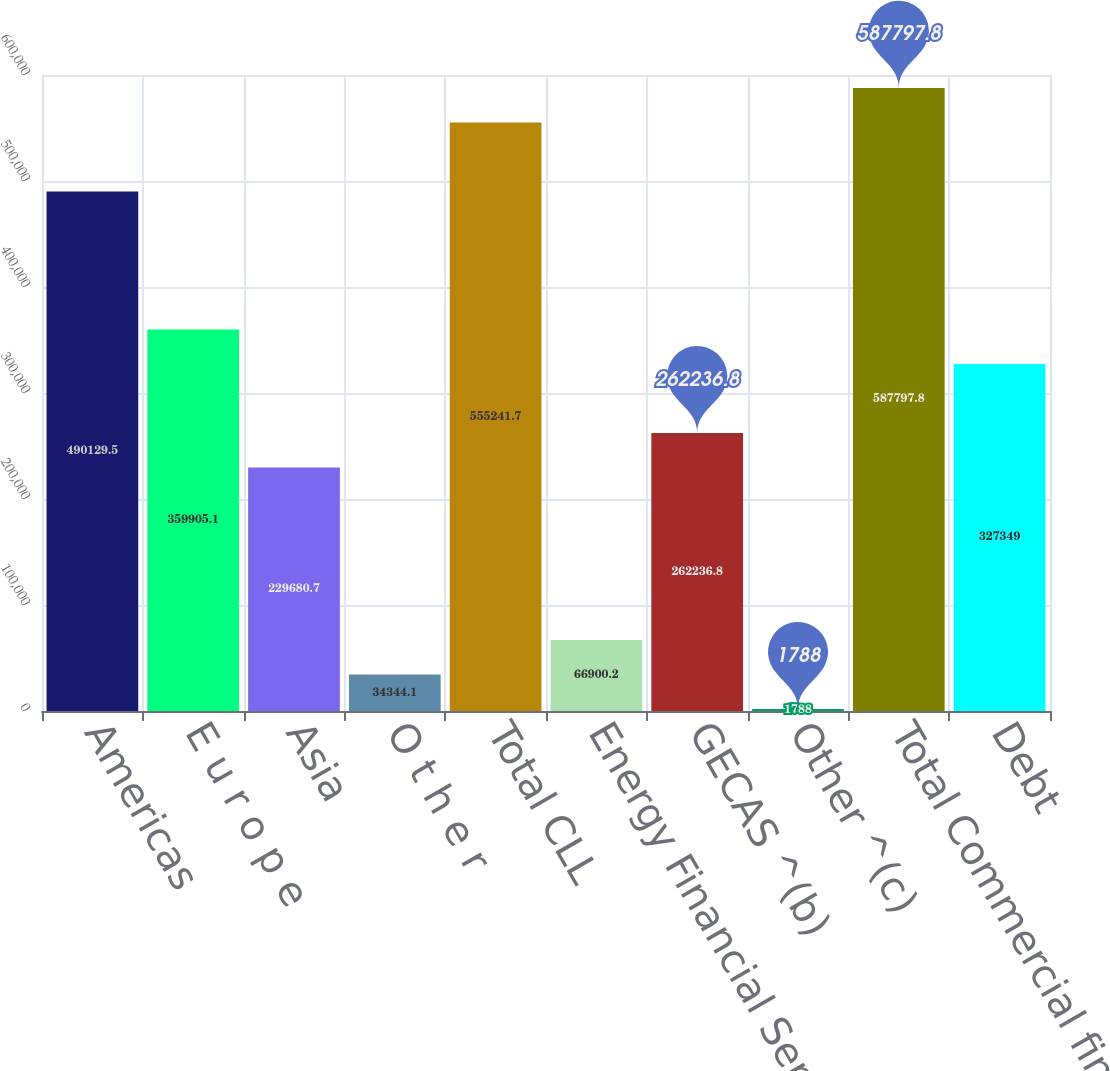Convert chart. <chart><loc_0><loc_0><loc_500><loc_500><bar_chart><fcel>Americas<fcel>E u r o p e<fcel>Asia<fcel>O t h e r<fcel>Total CLL<fcel>Energy Financial Services<fcel>GECAS ^(b)<fcel>Other ^(c)<fcel>Total Commercial financing<fcel>Debt<nl><fcel>490130<fcel>359905<fcel>229681<fcel>34344.1<fcel>555242<fcel>66900.2<fcel>262237<fcel>1788<fcel>587798<fcel>327349<nl></chart> 